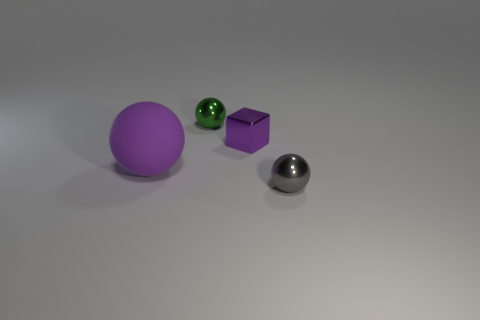Subtract all tiny metallic spheres. How many spheres are left? 1 Add 4 tiny green things. How many objects exist? 8 Subtract all cubes. How many objects are left? 3 Subtract 0 yellow blocks. How many objects are left? 4 Subtract all tiny matte cylinders. Subtract all large purple balls. How many objects are left? 3 Add 4 shiny objects. How many shiny objects are left? 7 Add 2 tiny brown rubber cubes. How many tiny brown rubber cubes exist? 2 